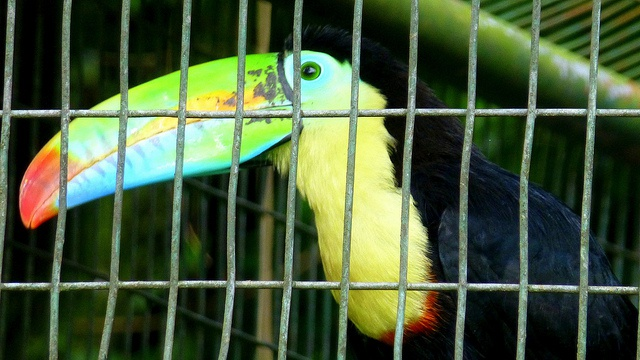Describe the objects in this image and their specific colors. I can see a bird in black, khaki, and beige tones in this image. 